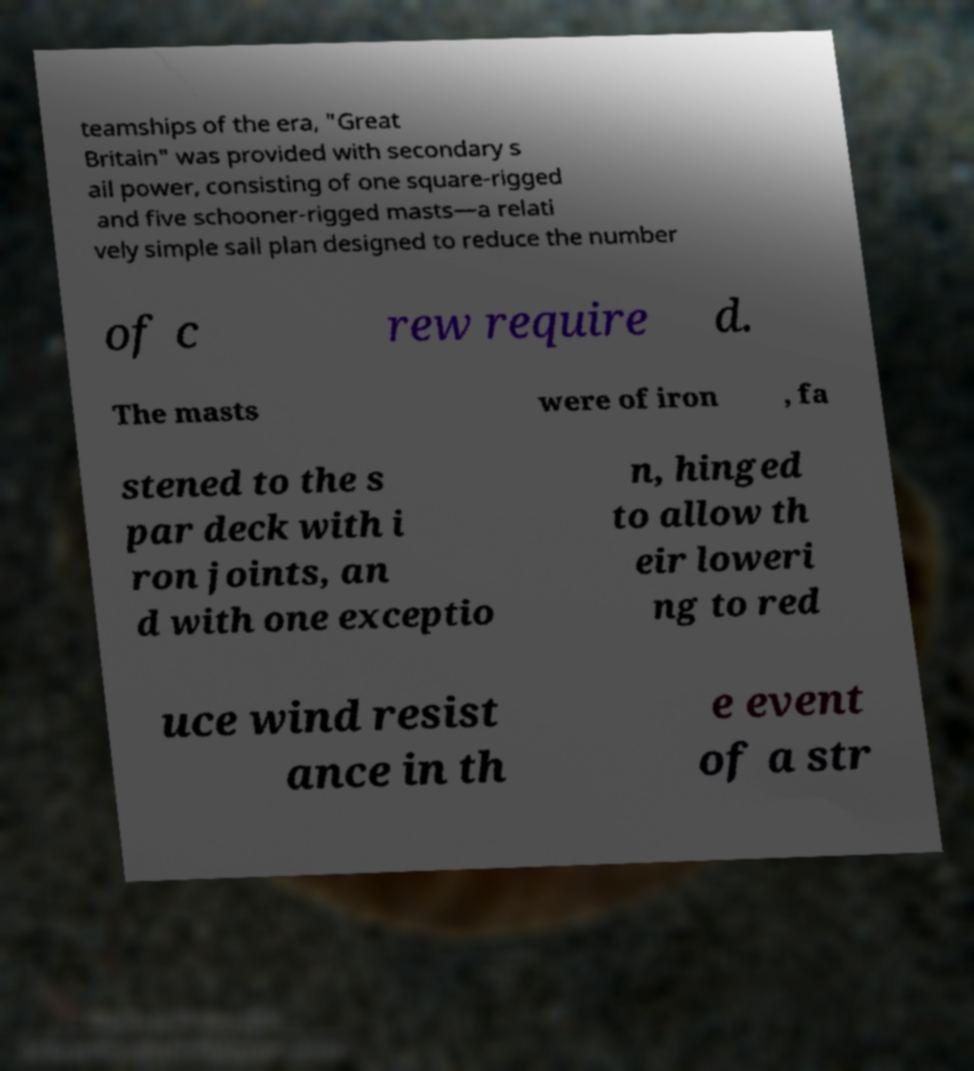Can you read and provide the text displayed in the image?This photo seems to have some interesting text. Can you extract and type it out for me? teamships of the era, "Great Britain" was provided with secondary s ail power, consisting of one square-rigged and five schooner-rigged masts—a relati vely simple sail plan designed to reduce the number of c rew require d. The masts were of iron , fa stened to the s par deck with i ron joints, an d with one exceptio n, hinged to allow th eir loweri ng to red uce wind resist ance in th e event of a str 